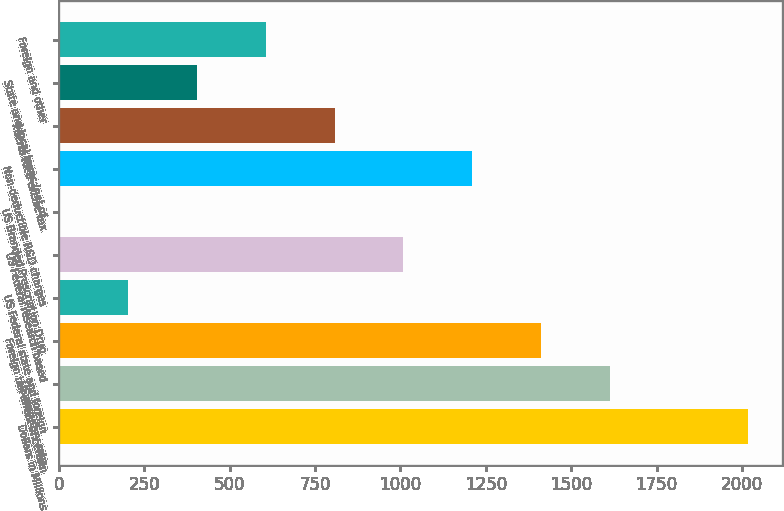Convert chart to OTSL. <chart><loc_0><loc_0><loc_500><loc_500><bar_chart><fcel>Dollars in Millions<fcel>US statutory rate<fcel>Foreign tax effect of certain<fcel>US Federal state and foreign<fcel>US Federal research based<fcel>US Branded Prescription Drug<fcel>Non-deductible R&D charges<fcel>Puerto Rico excise tax<fcel>State and local taxes (net of<fcel>Foreign and other<nl><fcel>2017<fcel>1613.8<fcel>1412.2<fcel>202.6<fcel>1009<fcel>1<fcel>1210.6<fcel>807.4<fcel>404.2<fcel>605.8<nl></chart> 